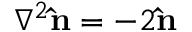<formula> <loc_0><loc_0><loc_500><loc_500>\nabla ^ { 2 } \hat { n } = - 2 \hat { n }</formula> 